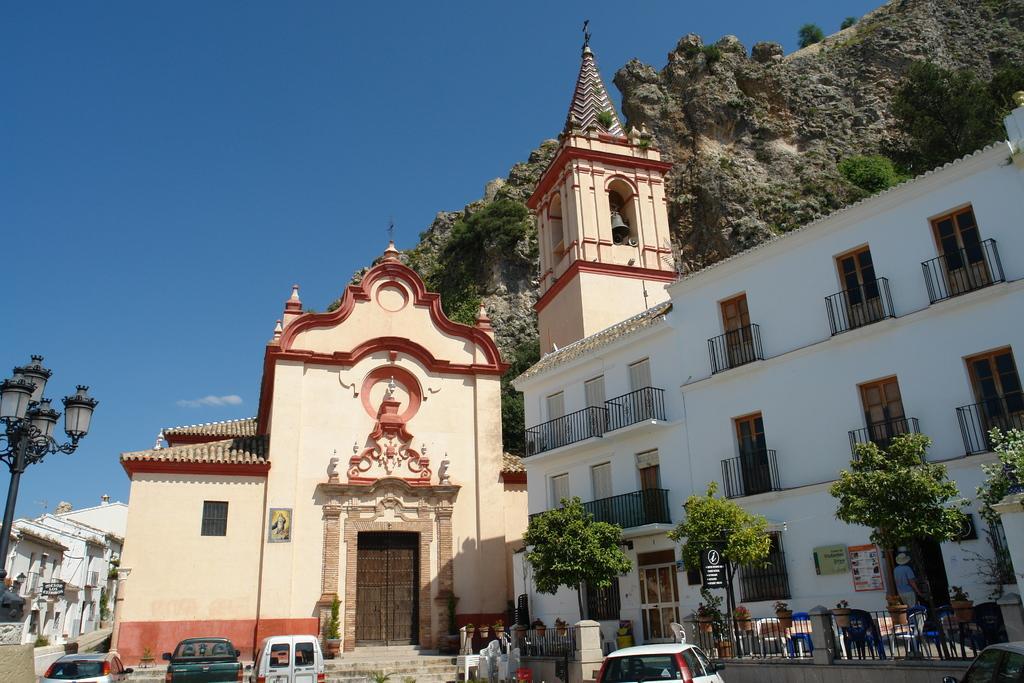In one or two sentences, can you explain what this image depicts? In the foreground I can see four cars on the road, trees, fence, light pole, buildings, doors, windows, boards, tower and a person. In the background I can see mountains, grass and the sky. This image is taken may be during a day. 